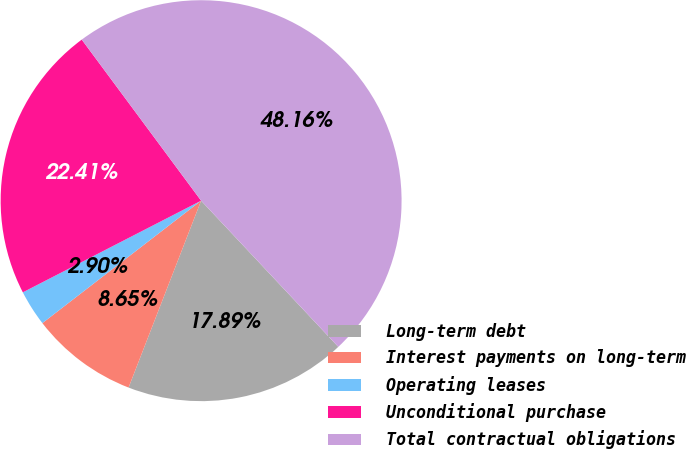Convert chart. <chart><loc_0><loc_0><loc_500><loc_500><pie_chart><fcel>Long-term debt<fcel>Interest payments on long-term<fcel>Operating leases<fcel>Unconditional purchase<fcel>Total contractual obligations<nl><fcel>17.89%<fcel>8.65%<fcel>2.9%<fcel>22.41%<fcel>48.16%<nl></chart> 